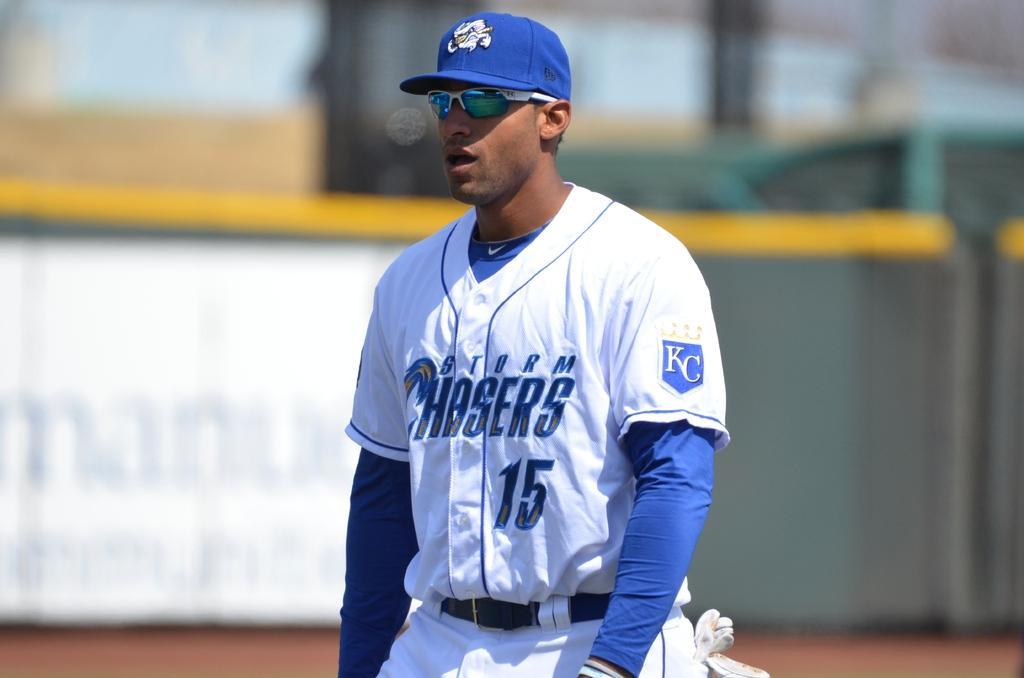<image>
Create a compact narrative representing the image presented. The player here is from the team called the Chaser's 